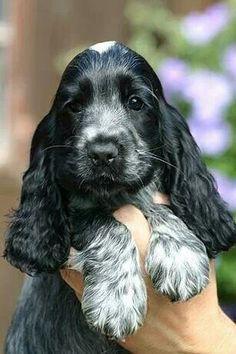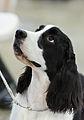The first image is the image on the left, the second image is the image on the right. For the images displayed, is the sentence "A human is touching the dog in the image on the left." factually correct? Answer yes or no. Yes. The first image is the image on the left, the second image is the image on the right. For the images displayed, is the sentence "The left image contains a human hand touching a black and white dog." factually correct? Answer yes or no. Yes. 